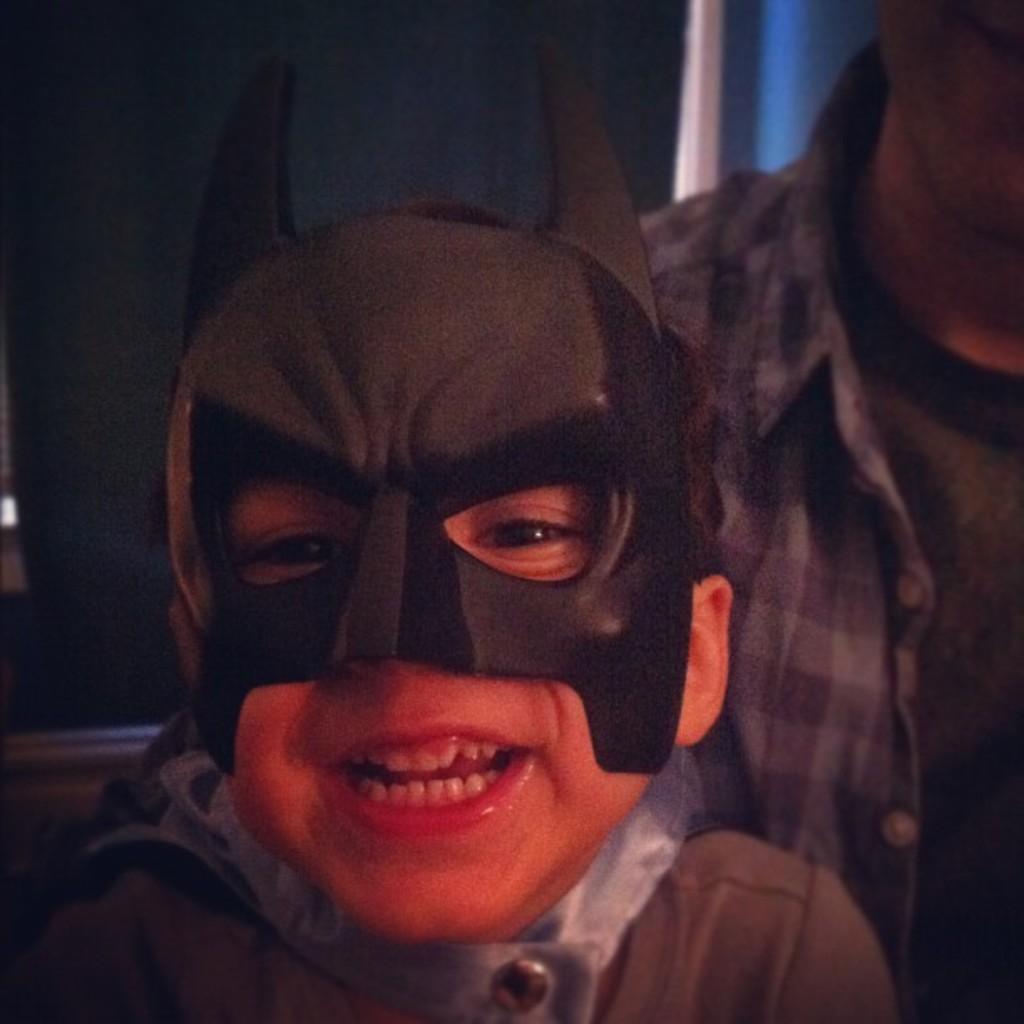Please provide a concise description of this image. In this picture there is a person with mask in the foreground. On the right side of the image there is a man. At the back it looks like a wall. 